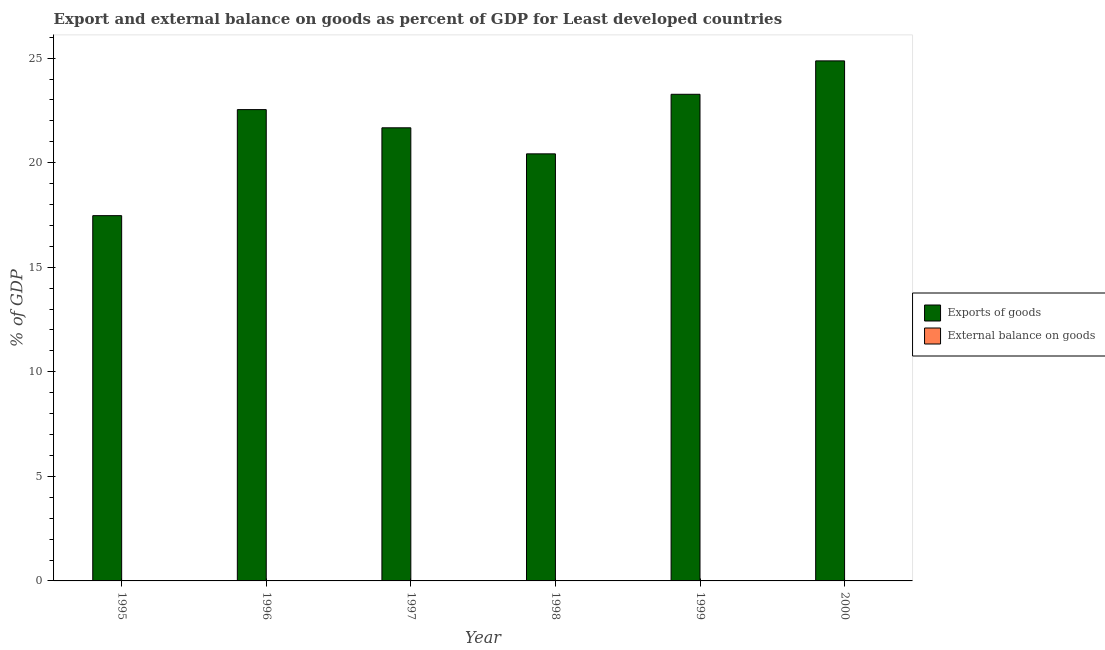How many different coloured bars are there?
Give a very brief answer. 1. Are the number of bars on each tick of the X-axis equal?
Provide a short and direct response. Yes. How many bars are there on the 2nd tick from the left?
Offer a terse response. 1. What is the label of the 3rd group of bars from the left?
Your answer should be compact. 1997. In how many cases, is the number of bars for a given year not equal to the number of legend labels?
Provide a succinct answer. 6. What is the export of goods as percentage of gdp in 1998?
Your response must be concise. 20.42. Across all years, what is the maximum export of goods as percentage of gdp?
Keep it short and to the point. 24.87. In which year was the export of goods as percentage of gdp maximum?
Provide a short and direct response. 2000. What is the total export of goods as percentage of gdp in the graph?
Your answer should be very brief. 130.24. What is the difference between the export of goods as percentage of gdp in 1997 and that in 2000?
Offer a very short reply. -3.2. What is the difference between the export of goods as percentage of gdp in 1997 and the external balance on goods as percentage of gdp in 1998?
Give a very brief answer. 1.25. What is the average export of goods as percentage of gdp per year?
Offer a terse response. 21.71. In how many years, is the external balance on goods as percentage of gdp greater than 11 %?
Ensure brevity in your answer.  0. What is the ratio of the export of goods as percentage of gdp in 1995 to that in 1996?
Ensure brevity in your answer.  0.78. Is the export of goods as percentage of gdp in 1998 less than that in 1999?
Offer a terse response. Yes. Is the difference between the export of goods as percentage of gdp in 1997 and 1998 greater than the difference between the external balance on goods as percentage of gdp in 1997 and 1998?
Offer a terse response. No. What is the difference between the highest and the second highest export of goods as percentage of gdp?
Keep it short and to the point. 1.6. What is the difference between the highest and the lowest export of goods as percentage of gdp?
Give a very brief answer. 7.4. In how many years, is the export of goods as percentage of gdp greater than the average export of goods as percentage of gdp taken over all years?
Your answer should be compact. 3. Is the sum of the export of goods as percentage of gdp in 1995 and 1996 greater than the maximum external balance on goods as percentage of gdp across all years?
Make the answer very short. Yes. Are all the bars in the graph horizontal?
Keep it short and to the point. No. How many years are there in the graph?
Provide a succinct answer. 6. What is the difference between two consecutive major ticks on the Y-axis?
Provide a short and direct response. 5. How are the legend labels stacked?
Your answer should be compact. Vertical. What is the title of the graph?
Offer a terse response. Export and external balance on goods as percent of GDP for Least developed countries. What is the label or title of the Y-axis?
Provide a succinct answer. % of GDP. What is the % of GDP of Exports of goods in 1995?
Offer a terse response. 17.47. What is the % of GDP of External balance on goods in 1995?
Provide a short and direct response. 0. What is the % of GDP of Exports of goods in 1996?
Make the answer very short. 22.54. What is the % of GDP of External balance on goods in 1996?
Ensure brevity in your answer.  0. What is the % of GDP in Exports of goods in 1997?
Give a very brief answer. 21.67. What is the % of GDP in External balance on goods in 1997?
Provide a short and direct response. 0. What is the % of GDP in Exports of goods in 1998?
Ensure brevity in your answer.  20.42. What is the % of GDP in External balance on goods in 1998?
Keep it short and to the point. 0. What is the % of GDP of Exports of goods in 1999?
Your answer should be very brief. 23.27. What is the % of GDP of External balance on goods in 1999?
Make the answer very short. 0. What is the % of GDP of Exports of goods in 2000?
Offer a very short reply. 24.87. Across all years, what is the maximum % of GDP in Exports of goods?
Your response must be concise. 24.87. Across all years, what is the minimum % of GDP of Exports of goods?
Keep it short and to the point. 17.47. What is the total % of GDP of Exports of goods in the graph?
Offer a very short reply. 130.24. What is the difference between the % of GDP of Exports of goods in 1995 and that in 1996?
Offer a very short reply. -5.07. What is the difference between the % of GDP of Exports of goods in 1995 and that in 1997?
Ensure brevity in your answer.  -4.2. What is the difference between the % of GDP in Exports of goods in 1995 and that in 1998?
Provide a succinct answer. -2.95. What is the difference between the % of GDP in Exports of goods in 1995 and that in 1999?
Ensure brevity in your answer.  -5.8. What is the difference between the % of GDP of Exports of goods in 1995 and that in 2000?
Make the answer very short. -7.4. What is the difference between the % of GDP of Exports of goods in 1996 and that in 1997?
Your answer should be very brief. 0.87. What is the difference between the % of GDP of Exports of goods in 1996 and that in 1998?
Provide a succinct answer. 2.12. What is the difference between the % of GDP in Exports of goods in 1996 and that in 1999?
Your answer should be compact. -0.73. What is the difference between the % of GDP of Exports of goods in 1996 and that in 2000?
Provide a succinct answer. -2.33. What is the difference between the % of GDP of Exports of goods in 1997 and that in 1998?
Offer a terse response. 1.25. What is the difference between the % of GDP in Exports of goods in 1997 and that in 1999?
Your answer should be very brief. -1.6. What is the difference between the % of GDP in Exports of goods in 1997 and that in 2000?
Provide a short and direct response. -3.2. What is the difference between the % of GDP of Exports of goods in 1998 and that in 1999?
Give a very brief answer. -2.85. What is the difference between the % of GDP of Exports of goods in 1998 and that in 2000?
Your response must be concise. -4.45. What is the difference between the % of GDP of Exports of goods in 1999 and that in 2000?
Your response must be concise. -1.6. What is the average % of GDP of Exports of goods per year?
Offer a very short reply. 21.71. What is the ratio of the % of GDP of Exports of goods in 1995 to that in 1996?
Keep it short and to the point. 0.78. What is the ratio of the % of GDP in Exports of goods in 1995 to that in 1997?
Give a very brief answer. 0.81. What is the ratio of the % of GDP of Exports of goods in 1995 to that in 1998?
Ensure brevity in your answer.  0.86. What is the ratio of the % of GDP of Exports of goods in 1995 to that in 1999?
Offer a very short reply. 0.75. What is the ratio of the % of GDP of Exports of goods in 1995 to that in 2000?
Ensure brevity in your answer.  0.7. What is the ratio of the % of GDP in Exports of goods in 1996 to that in 1997?
Your answer should be compact. 1.04. What is the ratio of the % of GDP in Exports of goods in 1996 to that in 1998?
Your answer should be very brief. 1.1. What is the ratio of the % of GDP in Exports of goods in 1996 to that in 1999?
Your response must be concise. 0.97. What is the ratio of the % of GDP in Exports of goods in 1996 to that in 2000?
Your answer should be very brief. 0.91. What is the ratio of the % of GDP of Exports of goods in 1997 to that in 1998?
Give a very brief answer. 1.06. What is the ratio of the % of GDP in Exports of goods in 1997 to that in 1999?
Keep it short and to the point. 0.93. What is the ratio of the % of GDP of Exports of goods in 1997 to that in 2000?
Ensure brevity in your answer.  0.87. What is the ratio of the % of GDP of Exports of goods in 1998 to that in 1999?
Your response must be concise. 0.88. What is the ratio of the % of GDP in Exports of goods in 1998 to that in 2000?
Give a very brief answer. 0.82. What is the ratio of the % of GDP of Exports of goods in 1999 to that in 2000?
Keep it short and to the point. 0.94. What is the difference between the highest and the second highest % of GDP of Exports of goods?
Give a very brief answer. 1.6. What is the difference between the highest and the lowest % of GDP in Exports of goods?
Offer a terse response. 7.4. 